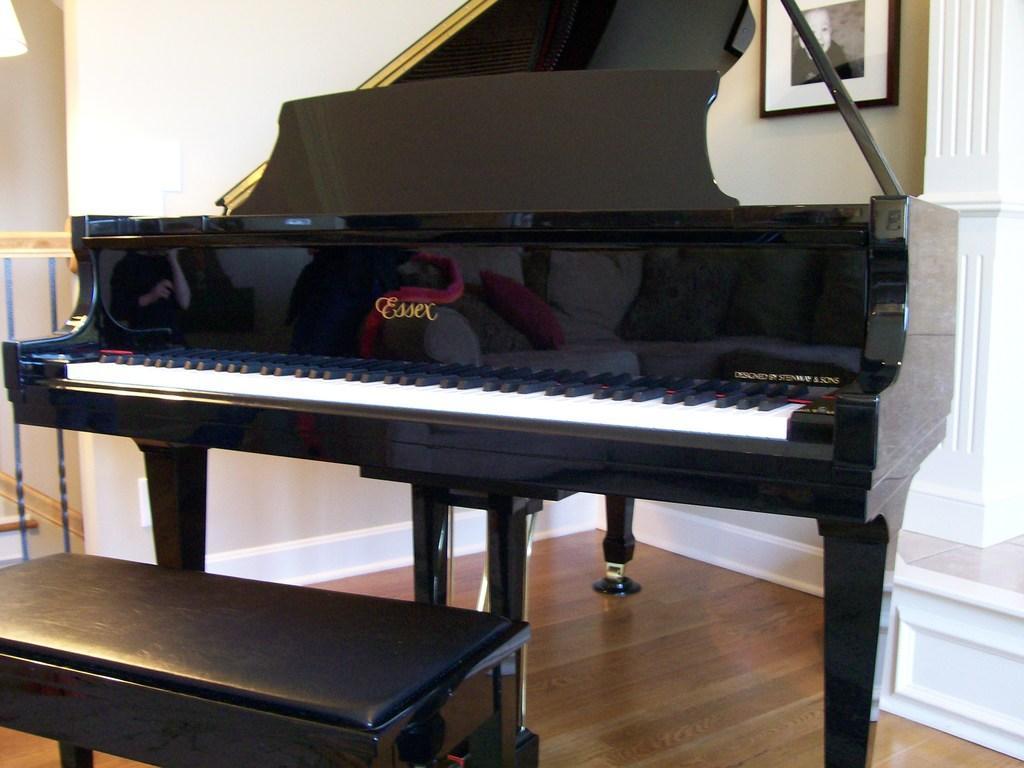Describe this image in one or two sentences. In this picture there is a piano which has black and white keys on it. There is a black bench. To the right, a frame is visible on the wall. To the left, a lump is seen. 